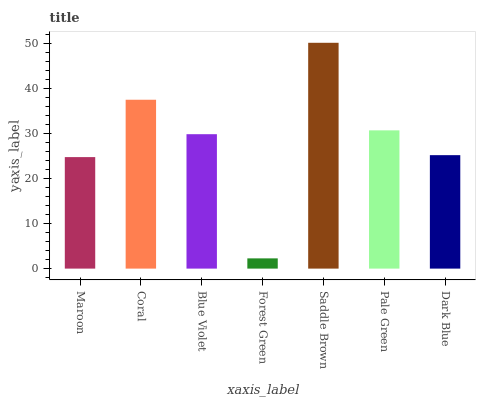Is Forest Green the minimum?
Answer yes or no. Yes. Is Saddle Brown the maximum?
Answer yes or no. Yes. Is Coral the minimum?
Answer yes or no. No. Is Coral the maximum?
Answer yes or no. No. Is Coral greater than Maroon?
Answer yes or no. Yes. Is Maroon less than Coral?
Answer yes or no. Yes. Is Maroon greater than Coral?
Answer yes or no. No. Is Coral less than Maroon?
Answer yes or no. No. Is Blue Violet the high median?
Answer yes or no. Yes. Is Blue Violet the low median?
Answer yes or no. Yes. Is Saddle Brown the high median?
Answer yes or no. No. Is Dark Blue the low median?
Answer yes or no. No. 